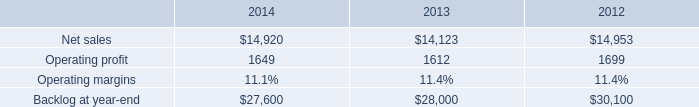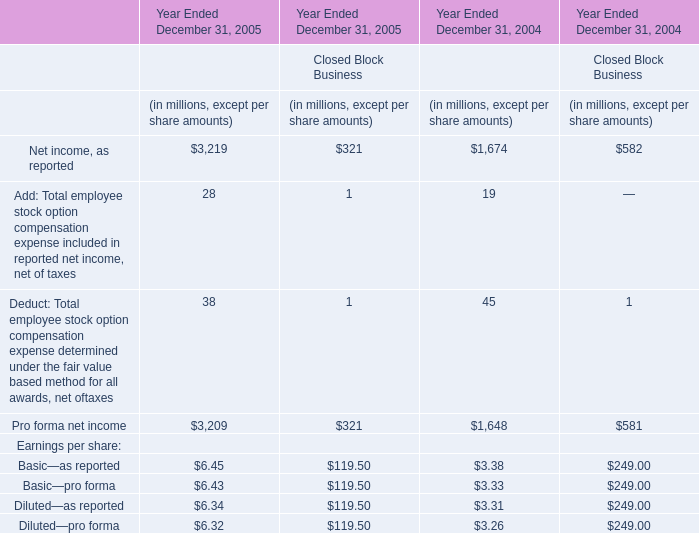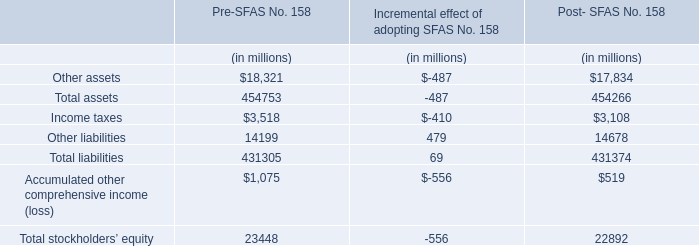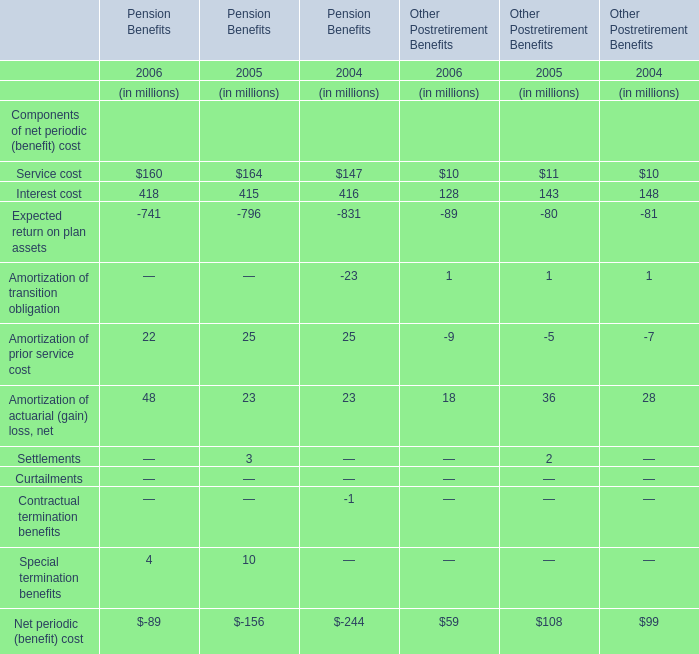what is the growth rate in operating profit for aeronautics in 2013? 
Computations: ((1612 - 1699) / 1699)
Answer: -0.05121. 